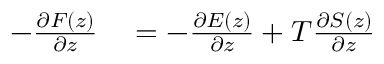<formula> <loc_0><loc_0><loc_500><loc_500>\begin{array} { r l } { - \frac { \partial F ( z ) } { \partial z } } & = - \frac { \partial E ( z ) } { \partial z } + T \frac { \partial S ( z ) } { \partial z } } \end{array}</formula> 